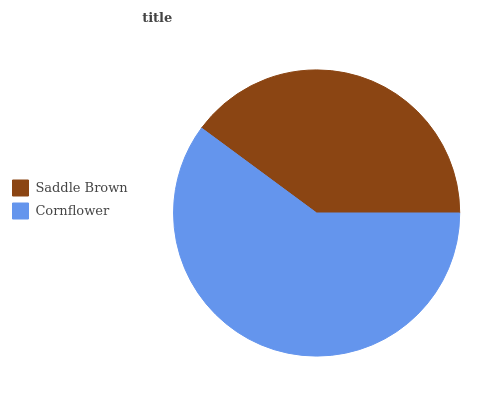Is Saddle Brown the minimum?
Answer yes or no. Yes. Is Cornflower the maximum?
Answer yes or no. Yes. Is Cornflower the minimum?
Answer yes or no. No. Is Cornflower greater than Saddle Brown?
Answer yes or no. Yes. Is Saddle Brown less than Cornflower?
Answer yes or no. Yes. Is Saddle Brown greater than Cornflower?
Answer yes or no. No. Is Cornflower less than Saddle Brown?
Answer yes or no. No. Is Cornflower the high median?
Answer yes or no. Yes. Is Saddle Brown the low median?
Answer yes or no. Yes. Is Saddle Brown the high median?
Answer yes or no. No. Is Cornflower the low median?
Answer yes or no. No. 